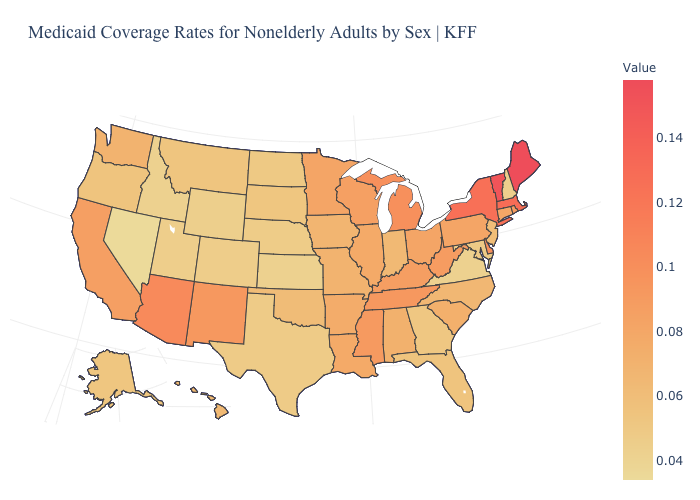Which states have the highest value in the USA?
Short answer required. Maine. Which states have the lowest value in the MidWest?
Keep it brief. Kansas. Does New Mexico have a lower value than Iowa?
Be succinct. No. Is the legend a continuous bar?
Write a very short answer. Yes. Does Minnesota have the lowest value in the USA?
Keep it brief. No. Which states have the highest value in the USA?
Give a very brief answer. Maine. Does Maine have the highest value in the Northeast?
Short answer required. Yes. 